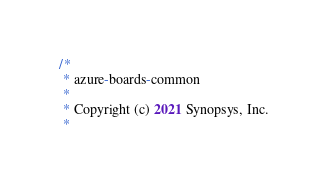<code> <loc_0><loc_0><loc_500><loc_500><_Java_>/*
 * azure-boards-common
 *
 * Copyright (c) 2021 Synopsys, Inc.
 *</code> 